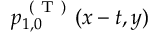Convert formula to latex. <formula><loc_0><loc_0><loc_500><loc_500>p _ { 1 , 0 } ^ { ( T ) } ( x - t , y )</formula> 